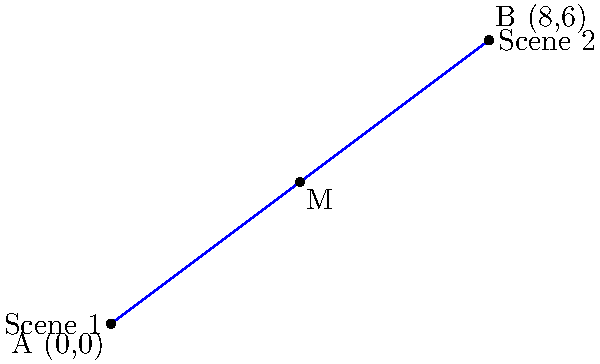As a method actor preparing for a physically demanding role, you're mapping out scene transitions on a coordinate plane. Scene 1 is at point A (0,0), and Scene 2 is at point B (8,6). To plan a smooth transition, you need to find the midpoint M between these two scenes. What are the coordinates of the midpoint M? To find the midpoint M between two points A(x₁, y₁) and B(x₂, y₂), we use the midpoint formula:

$$ M_x = \frac{x_1 + x_2}{2}, \quad M_y = \frac{y_1 + y_2}{2} $$

Given:
- Point A: (0, 0)
- Point B: (8, 6)

Step 1: Calculate the x-coordinate of the midpoint:
$$ M_x = \frac{0 + 8}{2} = \frac{8}{2} = 4 $$

Step 2: Calculate the y-coordinate of the midpoint:
$$ M_y = \frac{0 + 6}{2} = \frac{6}{2} = 3 $$

Therefore, the coordinates of the midpoint M are (4, 3).
Answer: (4, 3) 